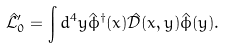<formula> <loc_0><loc_0><loc_500><loc_500>\hat { \mathcal { L } } _ { 0 } ^ { \prime } = \int d ^ { 4 } y \hat { \phi } ^ { \dagger } ( x ) \hat { \mathcal { D } } ( x , y ) \hat { \phi } ( y ) .</formula> 